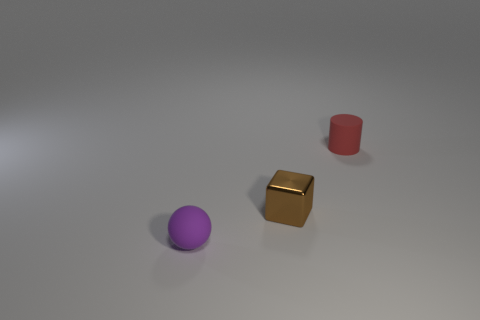What size is the matte object behind the tiny rubber object that is in front of the small red matte thing?
Make the answer very short. Small. Are there any other things that have the same shape as the purple thing?
Offer a very short reply. No. Is the number of red things less than the number of matte things?
Your answer should be very brief. Yes. There is a tiny object that is to the right of the sphere and left of the red cylinder; what is its material?
Your answer should be compact. Metal. There is a tiny matte object that is in front of the tiny red object; is there a rubber object that is behind it?
Ensure brevity in your answer.  Yes. How many things are either cubes or tiny matte objects?
Offer a very short reply. 3. Is the small object that is right of the tiny brown metallic cube made of the same material as the block?
Provide a succinct answer. No. How many objects are yellow metal cylinders or things right of the small brown cube?
Offer a terse response. 1. The other small thing that is made of the same material as the tiny red object is what color?
Ensure brevity in your answer.  Purple. How many small purple spheres are the same material as the tiny red object?
Your answer should be very brief. 1. 